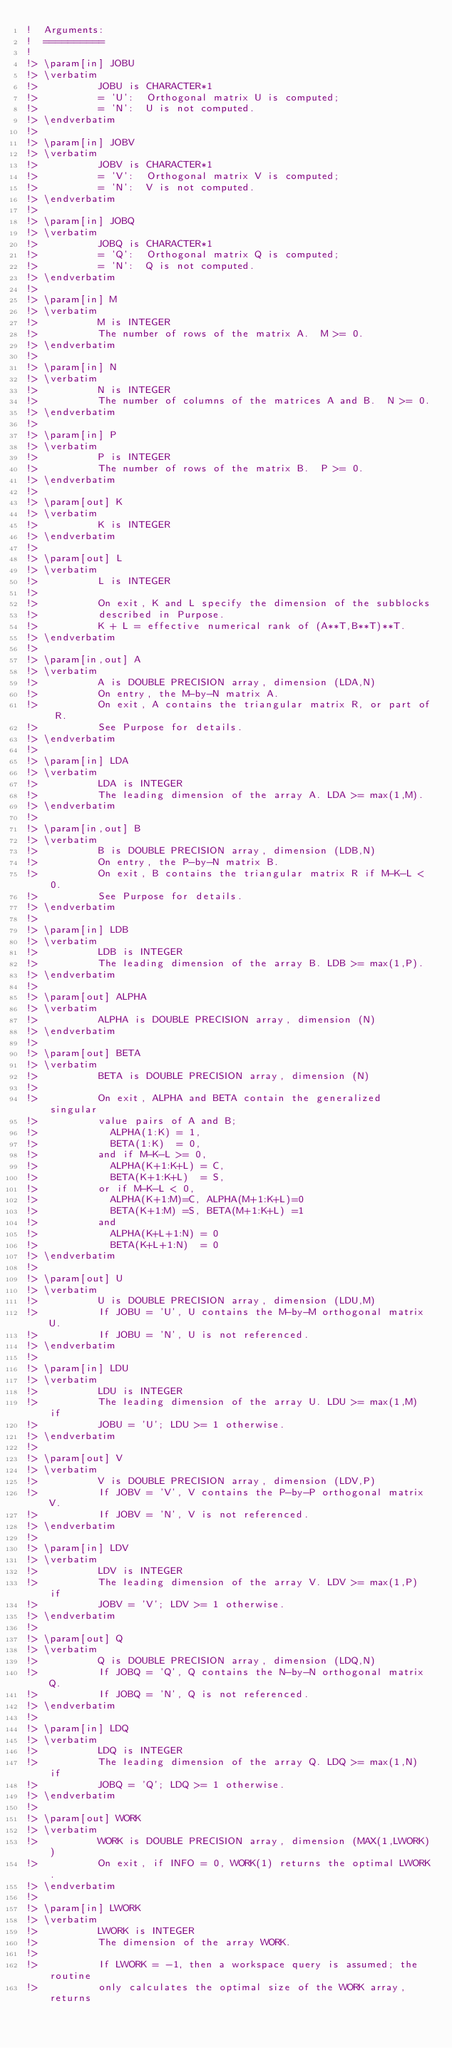Convert code to text. <code><loc_0><loc_0><loc_500><loc_500><_FORTRAN_>!  Arguments:
!  ==========
!
!> \param[in] JOBU
!> \verbatim
!>          JOBU is CHARACTER*1
!>          = 'U':  Orthogonal matrix U is computed;
!>          = 'N':  U is not computed.
!> \endverbatim
!>
!> \param[in] JOBV
!> \verbatim
!>          JOBV is CHARACTER*1
!>          = 'V':  Orthogonal matrix V is computed;
!>          = 'N':  V is not computed.
!> \endverbatim
!>
!> \param[in] JOBQ
!> \verbatim
!>          JOBQ is CHARACTER*1
!>          = 'Q':  Orthogonal matrix Q is computed;
!>          = 'N':  Q is not computed.
!> \endverbatim
!>
!> \param[in] M
!> \verbatim
!>          M is INTEGER
!>          The number of rows of the matrix A.  M >= 0.
!> \endverbatim
!>
!> \param[in] N
!> \verbatim
!>          N is INTEGER
!>          The number of columns of the matrices A and B.  N >= 0.
!> \endverbatim
!>
!> \param[in] P
!> \verbatim
!>          P is INTEGER
!>          The number of rows of the matrix B.  P >= 0.
!> \endverbatim
!>
!> \param[out] K
!> \verbatim
!>          K is INTEGER
!> \endverbatim
!>
!> \param[out] L
!> \verbatim
!>          L is INTEGER
!>
!>          On exit, K and L specify the dimension of the subblocks
!>          described in Purpose.
!>          K + L = effective numerical rank of (A**T,B**T)**T.
!> \endverbatim
!>
!> \param[in,out] A
!> \verbatim
!>          A is DOUBLE PRECISION array, dimension (LDA,N)
!>          On entry, the M-by-N matrix A.
!>          On exit, A contains the triangular matrix R, or part of R.
!>          See Purpose for details.
!> \endverbatim
!>
!> \param[in] LDA
!> \verbatim
!>          LDA is INTEGER
!>          The leading dimension of the array A. LDA >= max(1,M).
!> \endverbatim
!>
!> \param[in,out] B
!> \verbatim
!>          B is DOUBLE PRECISION array, dimension (LDB,N)
!>          On entry, the P-by-N matrix B.
!>          On exit, B contains the triangular matrix R if M-K-L < 0.
!>          See Purpose for details.
!> \endverbatim
!>
!> \param[in] LDB
!> \verbatim
!>          LDB is INTEGER
!>          The leading dimension of the array B. LDB >= max(1,P).
!> \endverbatim
!>
!> \param[out] ALPHA
!> \verbatim
!>          ALPHA is DOUBLE PRECISION array, dimension (N)
!> \endverbatim
!>
!> \param[out] BETA
!> \verbatim
!>          BETA is DOUBLE PRECISION array, dimension (N)
!>
!>          On exit, ALPHA and BETA contain the generalized singular
!>          value pairs of A and B;
!>            ALPHA(1:K) = 1,
!>            BETA(1:K)  = 0,
!>          and if M-K-L >= 0,
!>            ALPHA(K+1:K+L) = C,
!>            BETA(K+1:K+L)  = S,
!>          or if M-K-L < 0,
!>            ALPHA(K+1:M)=C, ALPHA(M+1:K+L)=0
!>            BETA(K+1:M) =S, BETA(M+1:K+L) =1
!>          and
!>            ALPHA(K+L+1:N) = 0
!>            BETA(K+L+1:N)  = 0
!> \endverbatim
!>
!> \param[out] U
!> \verbatim
!>          U is DOUBLE PRECISION array, dimension (LDU,M)
!>          If JOBU = 'U', U contains the M-by-M orthogonal matrix U.
!>          If JOBU = 'N', U is not referenced.
!> \endverbatim
!>
!> \param[in] LDU
!> \verbatim
!>          LDU is INTEGER
!>          The leading dimension of the array U. LDU >= max(1,M) if
!>          JOBU = 'U'; LDU >= 1 otherwise.
!> \endverbatim
!>
!> \param[out] V
!> \verbatim
!>          V is DOUBLE PRECISION array, dimension (LDV,P)
!>          If JOBV = 'V', V contains the P-by-P orthogonal matrix V.
!>          If JOBV = 'N', V is not referenced.
!> \endverbatim
!>
!> \param[in] LDV
!> \verbatim
!>          LDV is INTEGER
!>          The leading dimension of the array V. LDV >= max(1,P) if
!>          JOBV = 'V'; LDV >= 1 otherwise.
!> \endverbatim
!>
!> \param[out] Q
!> \verbatim
!>          Q is DOUBLE PRECISION array, dimension (LDQ,N)
!>          If JOBQ = 'Q', Q contains the N-by-N orthogonal matrix Q.
!>          If JOBQ = 'N', Q is not referenced.
!> \endverbatim
!>
!> \param[in] LDQ
!> \verbatim
!>          LDQ is INTEGER
!>          The leading dimension of the array Q. LDQ >= max(1,N) if
!>          JOBQ = 'Q'; LDQ >= 1 otherwise.
!> \endverbatim
!>
!> \param[out] WORK
!> \verbatim
!>          WORK is DOUBLE PRECISION array, dimension (MAX(1,LWORK))
!>          On exit, if INFO = 0, WORK(1) returns the optimal LWORK.
!> \endverbatim
!>
!> \param[in] LWORK
!> \verbatim
!>          LWORK is INTEGER
!>          The dimension of the array WORK.
!>
!>          If LWORK = -1, then a workspace query is assumed; the routine
!>          only calculates the optimal size of the WORK array, returns</code> 